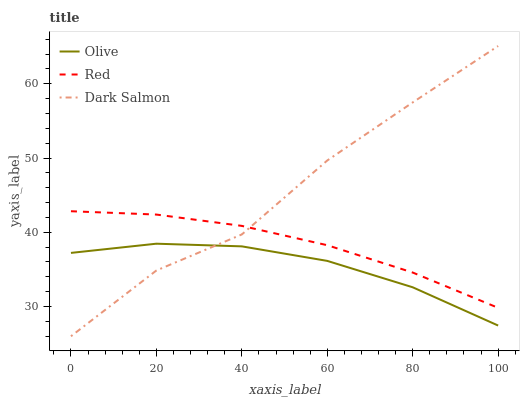Does Olive have the minimum area under the curve?
Answer yes or no. Yes. Does Dark Salmon have the maximum area under the curve?
Answer yes or no. Yes. Does Red have the minimum area under the curve?
Answer yes or no. No. Does Red have the maximum area under the curve?
Answer yes or no. No. Is Red the smoothest?
Answer yes or no. Yes. Is Dark Salmon the roughest?
Answer yes or no. Yes. Is Dark Salmon the smoothest?
Answer yes or no. No. Is Red the roughest?
Answer yes or no. No. Does Red have the lowest value?
Answer yes or no. No. Does Dark Salmon have the highest value?
Answer yes or no. Yes. Does Red have the highest value?
Answer yes or no. No. Is Olive less than Red?
Answer yes or no. Yes. Is Red greater than Olive?
Answer yes or no. Yes. Does Olive intersect Dark Salmon?
Answer yes or no. Yes. Is Olive less than Dark Salmon?
Answer yes or no. No. Is Olive greater than Dark Salmon?
Answer yes or no. No. Does Olive intersect Red?
Answer yes or no. No. 